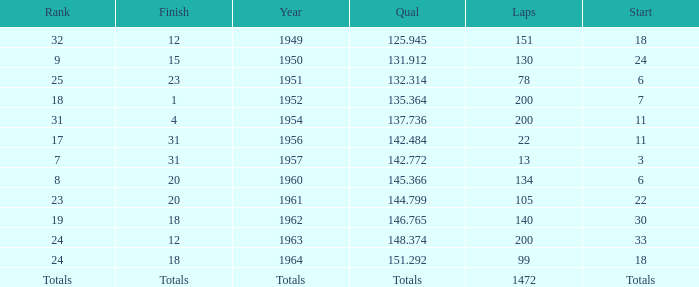What is the rank that has a conclusion of 12 and the year 1963? 24.0. 